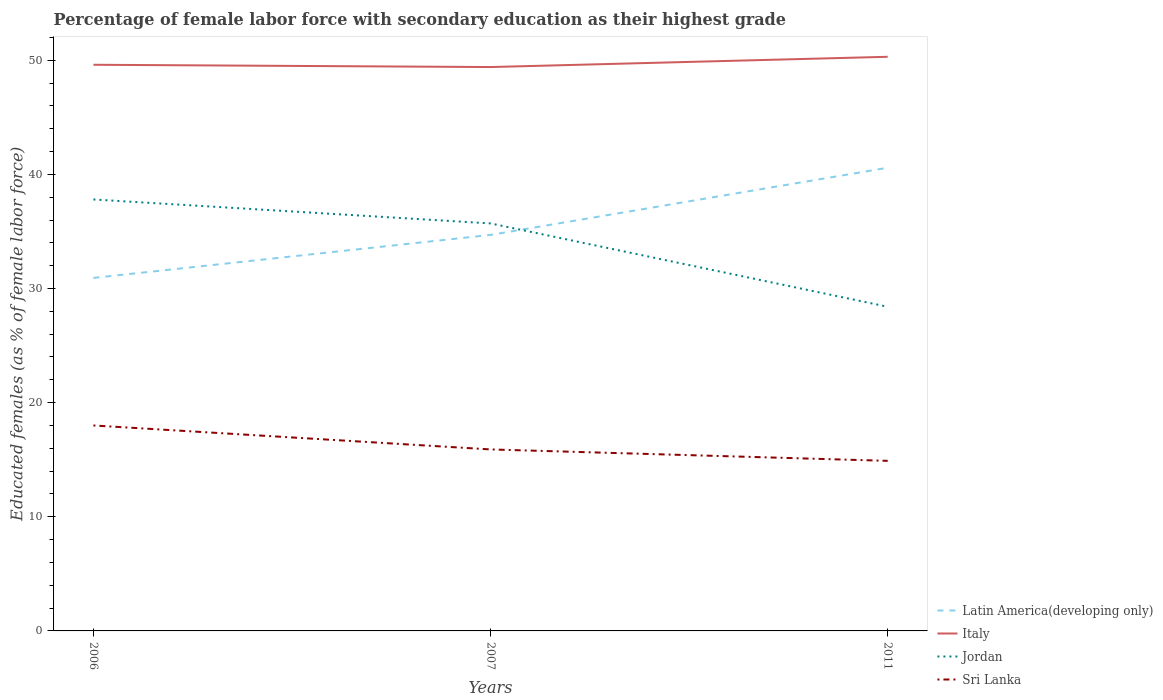Does the line corresponding to Latin America(developing only) intersect with the line corresponding to Italy?
Give a very brief answer. No. Across all years, what is the maximum percentage of female labor force with secondary education in Jordan?
Your answer should be compact. 28.4. What is the total percentage of female labor force with secondary education in Latin America(developing only) in the graph?
Your answer should be very brief. -3.77. What is the difference between the highest and the second highest percentage of female labor force with secondary education in Jordan?
Offer a very short reply. 9.4. What is the difference between the highest and the lowest percentage of female labor force with secondary education in Latin America(developing only)?
Your answer should be compact. 1. Is the percentage of female labor force with secondary education in Latin America(developing only) strictly greater than the percentage of female labor force with secondary education in Jordan over the years?
Your answer should be very brief. No. How many lines are there?
Offer a terse response. 4. How many years are there in the graph?
Provide a succinct answer. 3. Does the graph contain any zero values?
Make the answer very short. No. Does the graph contain grids?
Provide a succinct answer. No. How are the legend labels stacked?
Your response must be concise. Vertical. What is the title of the graph?
Your answer should be compact. Percentage of female labor force with secondary education as their highest grade. Does "Burkina Faso" appear as one of the legend labels in the graph?
Offer a terse response. No. What is the label or title of the X-axis?
Your response must be concise. Years. What is the label or title of the Y-axis?
Give a very brief answer. Educated females (as % of female labor force). What is the Educated females (as % of female labor force) in Latin America(developing only) in 2006?
Make the answer very short. 30.93. What is the Educated females (as % of female labor force) of Italy in 2006?
Offer a very short reply. 49.6. What is the Educated females (as % of female labor force) in Jordan in 2006?
Ensure brevity in your answer.  37.8. What is the Educated females (as % of female labor force) in Sri Lanka in 2006?
Your answer should be compact. 18. What is the Educated females (as % of female labor force) in Latin America(developing only) in 2007?
Keep it short and to the point. 34.69. What is the Educated females (as % of female labor force) in Italy in 2007?
Offer a terse response. 49.4. What is the Educated females (as % of female labor force) of Jordan in 2007?
Make the answer very short. 35.7. What is the Educated females (as % of female labor force) in Sri Lanka in 2007?
Give a very brief answer. 15.9. What is the Educated females (as % of female labor force) of Latin America(developing only) in 2011?
Provide a short and direct response. 40.58. What is the Educated females (as % of female labor force) in Italy in 2011?
Provide a succinct answer. 50.3. What is the Educated females (as % of female labor force) in Jordan in 2011?
Provide a succinct answer. 28.4. What is the Educated females (as % of female labor force) of Sri Lanka in 2011?
Make the answer very short. 14.9. Across all years, what is the maximum Educated females (as % of female labor force) in Latin America(developing only)?
Offer a terse response. 40.58. Across all years, what is the maximum Educated females (as % of female labor force) of Italy?
Offer a terse response. 50.3. Across all years, what is the maximum Educated females (as % of female labor force) of Jordan?
Your response must be concise. 37.8. Across all years, what is the maximum Educated females (as % of female labor force) in Sri Lanka?
Give a very brief answer. 18. Across all years, what is the minimum Educated females (as % of female labor force) of Latin America(developing only)?
Provide a short and direct response. 30.93. Across all years, what is the minimum Educated females (as % of female labor force) of Italy?
Provide a succinct answer. 49.4. Across all years, what is the minimum Educated females (as % of female labor force) in Jordan?
Make the answer very short. 28.4. Across all years, what is the minimum Educated females (as % of female labor force) in Sri Lanka?
Ensure brevity in your answer.  14.9. What is the total Educated females (as % of female labor force) of Latin America(developing only) in the graph?
Make the answer very short. 106.2. What is the total Educated females (as % of female labor force) of Italy in the graph?
Provide a succinct answer. 149.3. What is the total Educated females (as % of female labor force) in Jordan in the graph?
Offer a very short reply. 101.9. What is the total Educated females (as % of female labor force) of Sri Lanka in the graph?
Give a very brief answer. 48.8. What is the difference between the Educated females (as % of female labor force) in Latin America(developing only) in 2006 and that in 2007?
Make the answer very short. -3.77. What is the difference between the Educated females (as % of female labor force) in Latin America(developing only) in 2006 and that in 2011?
Keep it short and to the point. -9.65. What is the difference between the Educated females (as % of female labor force) in Latin America(developing only) in 2007 and that in 2011?
Your answer should be very brief. -5.88. What is the difference between the Educated females (as % of female labor force) of Latin America(developing only) in 2006 and the Educated females (as % of female labor force) of Italy in 2007?
Give a very brief answer. -18.47. What is the difference between the Educated females (as % of female labor force) of Latin America(developing only) in 2006 and the Educated females (as % of female labor force) of Jordan in 2007?
Offer a terse response. -4.77. What is the difference between the Educated females (as % of female labor force) in Latin America(developing only) in 2006 and the Educated females (as % of female labor force) in Sri Lanka in 2007?
Your response must be concise. 15.03. What is the difference between the Educated females (as % of female labor force) of Italy in 2006 and the Educated females (as % of female labor force) of Sri Lanka in 2007?
Give a very brief answer. 33.7. What is the difference between the Educated females (as % of female labor force) in Jordan in 2006 and the Educated females (as % of female labor force) in Sri Lanka in 2007?
Make the answer very short. 21.9. What is the difference between the Educated females (as % of female labor force) in Latin America(developing only) in 2006 and the Educated females (as % of female labor force) in Italy in 2011?
Give a very brief answer. -19.37. What is the difference between the Educated females (as % of female labor force) in Latin America(developing only) in 2006 and the Educated females (as % of female labor force) in Jordan in 2011?
Your answer should be compact. 2.53. What is the difference between the Educated females (as % of female labor force) in Latin America(developing only) in 2006 and the Educated females (as % of female labor force) in Sri Lanka in 2011?
Provide a succinct answer. 16.03. What is the difference between the Educated females (as % of female labor force) of Italy in 2006 and the Educated females (as % of female labor force) of Jordan in 2011?
Offer a very short reply. 21.2. What is the difference between the Educated females (as % of female labor force) of Italy in 2006 and the Educated females (as % of female labor force) of Sri Lanka in 2011?
Keep it short and to the point. 34.7. What is the difference between the Educated females (as % of female labor force) in Jordan in 2006 and the Educated females (as % of female labor force) in Sri Lanka in 2011?
Your answer should be compact. 22.9. What is the difference between the Educated females (as % of female labor force) of Latin America(developing only) in 2007 and the Educated females (as % of female labor force) of Italy in 2011?
Provide a succinct answer. -15.61. What is the difference between the Educated females (as % of female labor force) in Latin America(developing only) in 2007 and the Educated females (as % of female labor force) in Jordan in 2011?
Your answer should be compact. 6.29. What is the difference between the Educated females (as % of female labor force) in Latin America(developing only) in 2007 and the Educated females (as % of female labor force) in Sri Lanka in 2011?
Your answer should be very brief. 19.79. What is the difference between the Educated females (as % of female labor force) in Italy in 2007 and the Educated females (as % of female labor force) in Sri Lanka in 2011?
Offer a terse response. 34.5. What is the difference between the Educated females (as % of female labor force) of Jordan in 2007 and the Educated females (as % of female labor force) of Sri Lanka in 2011?
Your response must be concise. 20.8. What is the average Educated females (as % of female labor force) of Latin America(developing only) per year?
Offer a terse response. 35.4. What is the average Educated females (as % of female labor force) of Italy per year?
Give a very brief answer. 49.77. What is the average Educated females (as % of female labor force) in Jordan per year?
Offer a terse response. 33.97. What is the average Educated females (as % of female labor force) in Sri Lanka per year?
Make the answer very short. 16.27. In the year 2006, what is the difference between the Educated females (as % of female labor force) in Latin America(developing only) and Educated females (as % of female labor force) in Italy?
Keep it short and to the point. -18.67. In the year 2006, what is the difference between the Educated females (as % of female labor force) of Latin America(developing only) and Educated females (as % of female labor force) of Jordan?
Your answer should be very brief. -6.87. In the year 2006, what is the difference between the Educated females (as % of female labor force) in Latin America(developing only) and Educated females (as % of female labor force) in Sri Lanka?
Your answer should be very brief. 12.93. In the year 2006, what is the difference between the Educated females (as % of female labor force) of Italy and Educated females (as % of female labor force) of Sri Lanka?
Provide a succinct answer. 31.6. In the year 2006, what is the difference between the Educated females (as % of female labor force) in Jordan and Educated females (as % of female labor force) in Sri Lanka?
Keep it short and to the point. 19.8. In the year 2007, what is the difference between the Educated females (as % of female labor force) in Latin America(developing only) and Educated females (as % of female labor force) in Italy?
Give a very brief answer. -14.71. In the year 2007, what is the difference between the Educated females (as % of female labor force) of Latin America(developing only) and Educated females (as % of female labor force) of Jordan?
Your answer should be very brief. -1.01. In the year 2007, what is the difference between the Educated females (as % of female labor force) in Latin America(developing only) and Educated females (as % of female labor force) in Sri Lanka?
Your answer should be compact. 18.79. In the year 2007, what is the difference between the Educated females (as % of female labor force) of Italy and Educated females (as % of female labor force) of Jordan?
Make the answer very short. 13.7. In the year 2007, what is the difference between the Educated females (as % of female labor force) of Italy and Educated females (as % of female labor force) of Sri Lanka?
Provide a short and direct response. 33.5. In the year 2007, what is the difference between the Educated females (as % of female labor force) of Jordan and Educated females (as % of female labor force) of Sri Lanka?
Ensure brevity in your answer.  19.8. In the year 2011, what is the difference between the Educated females (as % of female labor force) of Latin America(developing only) and Educated females (as % of female labor force) of Italy?
Give a very brief answer. -9.72. In the year 2011, what is the difference between the Educated females (as % of female labor force) of Latin America(developing only) and Educated females (as % of female labor force) of Jordan?
Provide a short and direct response. 12.18. In the year 2011, what is the difference between the Educated females (as % of female labor force) in Latin America(developing only) and Educated females (as % of female labor force) in Sri Lanka?
Offer a terse response. 25.68. In the year 2011, what is the difference between the Educated females (as % of female labor force) in Italy and Educated females (as % of female labor force) in Jordan?
Provide a succinct answer. 21.9. In the year 2011, what is the difference between the Educated females (as % of female labor force) of Italy and Educated females (as % of female labor force) of Sri Lanka?
Offer a terse response. 35.4. In the year 2011, what is the difference between the Educated females (as % of female labor force) of Jordan and Educated females (as % of female labor force) of Sri Lanka?
Keep it short and to the point. 13.5. What is the ratio of the Educated females (as % of female labor force) of Latin America(developing only) in 2006 to that in 2007?
Ensure brevity in your answer.  0.89. What is the ratio of the Educated females (as % of female labor force) in Italy in 2006 to that in 2007?
Offer a terse response. 1. What is the ratio of the Educated females (as % of female labor force) in Jordan in 2006 to that in 2007?
Your response must be concise. 1.06. What is the ratio of the Educated females (as % of female labor force) of Sri Lanka in 2006 to that in 2007?
Make the answer very short. 1.13. What is the ratio of the Educated females (as % of female labor force) in Latin America(developing only) in 2006 to that in 2011?
Your answer should be very brief. 0.76. What is the ratio of the Educated females (as % of female labor force) in Italy in 2006 to that in 2011?
Provide a succinct answer. 0.99. What is the ratio of the Educated females (as % of female labor force) of Jordan in 2006 to that in 2011?
Keep it short and to the point. 1.33. What is the ratio of the Educated females (as % of female labor force) in Sri Lanka in 2006 to that in 2011?
Your answer should be very brief. 1.21. What is the ratio of the Educated females (as % of female labor force) in Latin America(developing only) in 2007 to that in 2011?
Offer a very short reply. 0.85. What is the ratio of the Educated females (as % of female labor force) of Italy in 2007 to that in 2011?
Give a very brief answer. 0.98. What is the ratio of the Educated females (as % of female labor force) of Jordan in 2007 to that in 2011?
Ensure brevity in your answer.  1.26. What is the ratio of the Educated females (as % of female labor force) of Sri Lanka in 2007 to that in 2011?
Ensure brevity in your answer.  1.07. What is the difference between the highest and the second highest Educated females (as % of female labor force) in Latin America(developing only)?
Provide a succinct answer. 5.88. What is the difference between the highest and the second highest Educated females (as % of female labor force) of Italy?
Your answer should be compact. 0.7. What is the difference between the highest and the second highest Educated females (as % of female labor force) of Jordan?
Ensure brevity in your answer.  2.1. What is the difference between the highest and the second highest Educated females (as % of female labor force) in Sri Lanka?
Your answer should be compact. 2.1. What is the difference between the highest and the lowest Educated females (as % of female labor force) of Latin America(developing only)?
Offer a very short reply. 9.65. What is the difference between the highest and the lowest Educated females (as % of female labor force) of Jordan?
Provide a short and direct response. 9.4. What is the difference between the highest and the lowest Educated females (as % of female labor force) of Sri Lanka?
Make the answer very short. 3.1. 